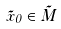Convert formula to latex. <formula><loc_0><loc_0><loc_500><loc_500>\tilde { x } _ { 0 } \in \tilde { M }</formula> 